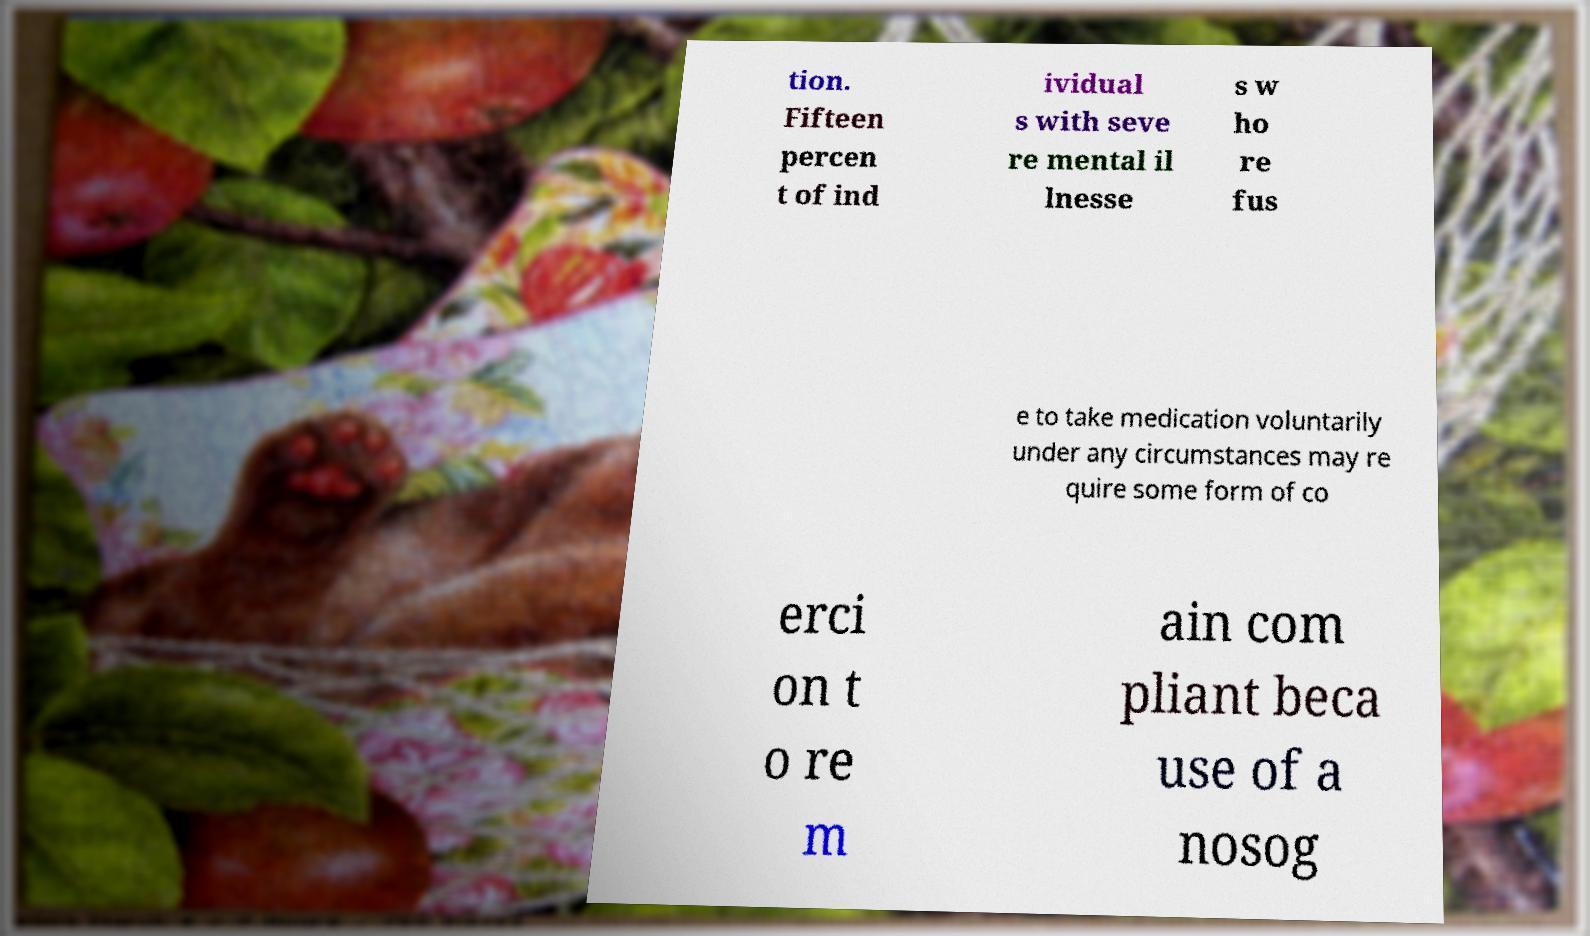Please read and relay the text visible in this image. What does it say? tion. Fifteen percen t of ind ividual s with seve re mental il lnesse s w ho re fus e to take medication voluntarily under any circumstances may re quire some form of co erci on t o re m ain com pliant beca use of a nosog 